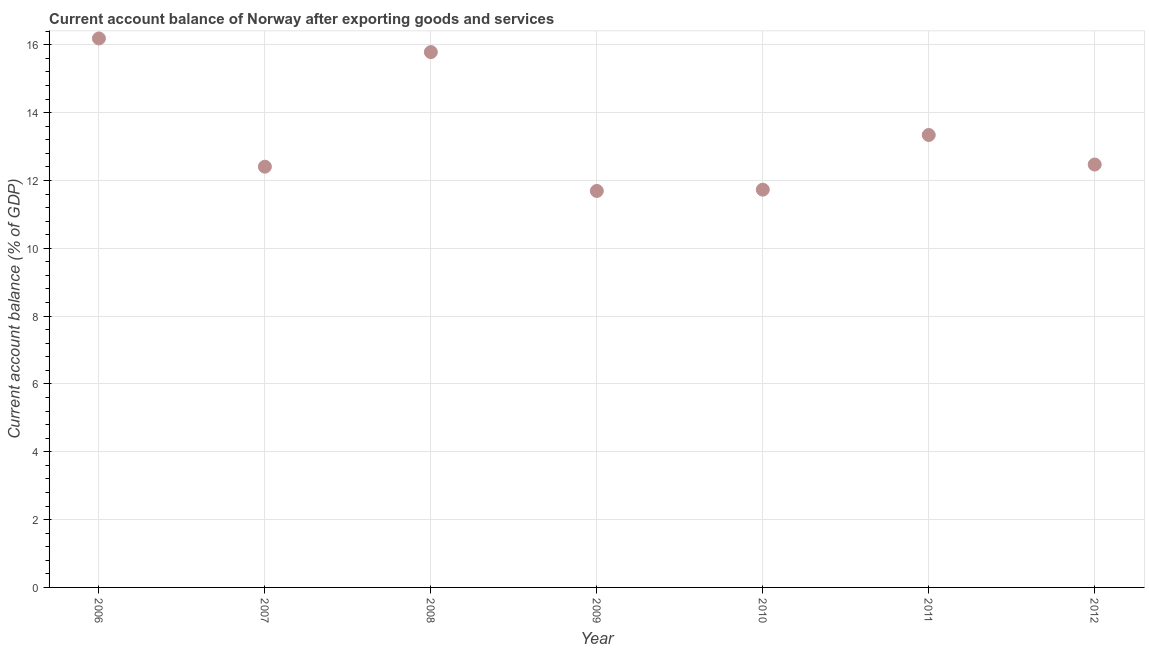What is the current account balance in 2010?
Keep it short and to the point. 11.73. Across all years, what is the maximum current account balance?
Your answer should be very brief. 16.19. Across all years, what is the minimum current account balance?
Make the answer very short. 11.69. What is the sum of the current account balance?
Provide a succinct answer. 93.6. What is the difference between the current account balance in 2006 and 2010?
Your answer should be very brief. 4.46. What is the average current account balance per year?
Keep it short and to the point. 13.37. What is the median current account balance?
Provide a short and direct response. 12.47. Do a majority of the years between 2007 and 2006 (inclusive) have current account balance greater than 12.8 %?
Offer a terse response. No. What is the ratio of the current account balance in 2006 to that in 2008?
Give a very brief answer. 1.03. Is the current account balance in 2009 less than that in 2011?
Ensure brevity in your answer.  Yes. What is the difference between the highest and the second highest current account balance?
Your answer should be compact. 0.4. Is the sum of the current account balance in 2007 and 2011 greater than the maximum current account balance across all years?
Your answer should be very brief. Yes. What is the difference between the highest and the lowest current account balance?
Offer a very short reply. 4.5. In how many years, is the current account balance greater than the average current account balance taken over all years?
Your answer should be very brief. 2. Does the current account balance monotonically increase over the years?
Your answer should be very brief. No. How many years are there in the graph?
Make the answer very short. 7. What is the difference between two consecutive major ticks on the Y-axis?
Ensure brevity in your answer.  2. Does the graph contain grids?
Ensure brevity in your answer.  Yes. What is the title of the graph?
Give a very brief answer. Current account balance of Norway after exporting goods and services. What is the label or title of the X-axis?
Your answer should be very brief. Year. What is the label or title of the Y-axis?
Keep it short and to the point. Current account balance (% of GDP). What is the Current account balance (% of GDP) in 2006?
Ensure brevity in your answer.  16.19. What is the Current account balance (% of GDP) in 2007?
Your answer should be very brief. 12.41. What is the Current account balance (% of GDP) in 2008?
Give a very brief answer. 15.78. What is the Current account balance (% of GDP) in 2009?
Keep it short and to the point. 11.69. What is the Current account balance (% of GDP) in 2010?
Your answer should be compact. 11.73. What is the Current account balance (% of GDP) in 2011?
Make the answer very short. 13.34. What is the Current account balance (% of GDP) in 2012?
Your answer should be compact. 12.47. What is the difference between the Current account balance (% of GDP) in 2006 and 2007?
Your answer should be compact. 3.78. What is the difference between the Current account balance (% of GDP) in 2006 and 2008?
Ensure brevity in your answer.  0.4. What is the difference between the Current account balance (% of GDP) in 2006 and 2009?
Provide a short and direct response. 4.5. What is the difference between the Current account balance (% of GDP) in 2006 and 2010?
Your response must be concise. 4.46. What is the difference between the Current account balance (% of GDP) in 2006 and 2011?
Offer a very short reply. 2.85. What is the difference between the Current account balance (% of GDP) in 2006 and 2012?
Give a very brief answer. 3.72. What is the difference between the Current account balance (% of GDP) in 2007 and 2008?
Your answer should be very brief. -3.38. What is the difference between the Current account balance (% of GDP) in 2007 and 2009?
Your answer should be compact. 0.72. What is the difference between the Current account balance (% of GDP) in 2007 and 2010?
Your response must be concise. 0.68. What is the difference between the Current account balance (% of GDP) in 2007 and 2011?
Provide a succinct answer. -0.93. What is the difference between the Current account balance (% of GDP) in 2007 and 2012?
Provide a short and direct response. -0.06. What is the difference between the Current account balance (% of GDP) in 2008 and 2009?
Your answer should be very brief. 4.09. What is the difference between the Current account balance (% of GDP) in 2008 and 2010?
Make the answer very short. 4.06. What is the difference between the Current account balance (% of GDP) in 2008 and 2011?
Your response must be concise. 2.44. What is the difference between the Current account balance (% of GDP) in 2008 and 2012?
Keep it short and to the point. 3.31. What is the difference between the Current account balance (% of GDP) in 2009 and 2010?
Make the answer very short. -0.04. What is the difference between the Current account balance (% of GDP) in 2009 and 2011?
Make the answer very short. -1.65. What is the difference between the Current account balance (% of GDP) in 2009 and 2012?
Offer a very short reply. -0.78. What is the difference between the Current account balance (% of GDP) in 2010 and 2011?
Offer a very short reply. -1.61. What is the difference between the Current account balance (% of GDP) in 2010 and 2012?
Offer a very short reply. -0.74. What is the difference between the Current account balance (% of GDP) in 2011 and 2012?
Offer a terse response. 0.87. What is the ratio of the Current account balance (% of GDP) in 2006 to that in 2007?
Your answer should be very brief. 1.3. What is the ratio of the Current account balance (% of GDP) in 2006 to that in 2009?
Offer a terse response. 1.39. What is the ratio of the Current account balance (% of GDP) in 2006 to that in 2010?
Provide a succinct answer. 1.38. What is the ratio of the Current account balance (% of GDP) in 2006 to that in 2011?
Offer a terse response. 1.21. What is the ratio of the Current account balance (% of GDP) in 2006 to that in 2012?
Offer a very short reply. 1.3. What is the ratio of the Current account balance (% of GDP) in 2007 to that in 2008?
Make the answer very short. 0.79. What is the ratio of the Current account balance (% of GDP) in 2007 to that in 2009?
Offer a terse response. 1.06. What is the ratio of the Current account balance (% of GDP) in 2007 to that in 2010?
Keep it short and to the point. 1.06. What is the ratio of the Current account balance (% of GDP) in 2007 to that in 2011?
Provide a succinct answer. 0.93. What is the ratio of the Current account balance (% of GDP) in 2007 to that in 2012?
Your response must be concise. 0.99. What is the ratio of the Current account balance (% of GDP) in 2008 to that in 2009?
Your answer should be very brief. 1.35. What is the ratio of the Current account balance (% of GDP) in 2008 to that in 2010?
Offer a very short reply. 1.35. What is the ratio of the Current account balance (% of GDP) in 2008 to that in 2011?
Give a very brief answer. 1.18. What is the ratio of the Current account balance (% of GDP) in 2008 to that in 2012?
Offer a terse response. 1.27. What is the ratio of the Current account balance (% of GDP) in 2009 to that in 2011?
Offer a terse response. 0.88. What is the ratio of the Current account balance (% of GDP) in 2009 to that in 2012?
Offer a terse response. 0.94. What is the ratio of the Current account balance (% of GDP) in 2010 to that in 2011?
Provide a succinct answer. 0.88. What is the ratio of the Current account balance (% of GDP) in 2010 to that in 2012?
Give a very brief answer. 0.94. What is the ratio of the Current account balance (% of GDP) in 2011 to that in 2012?
Your response must be concise. 1.07. 